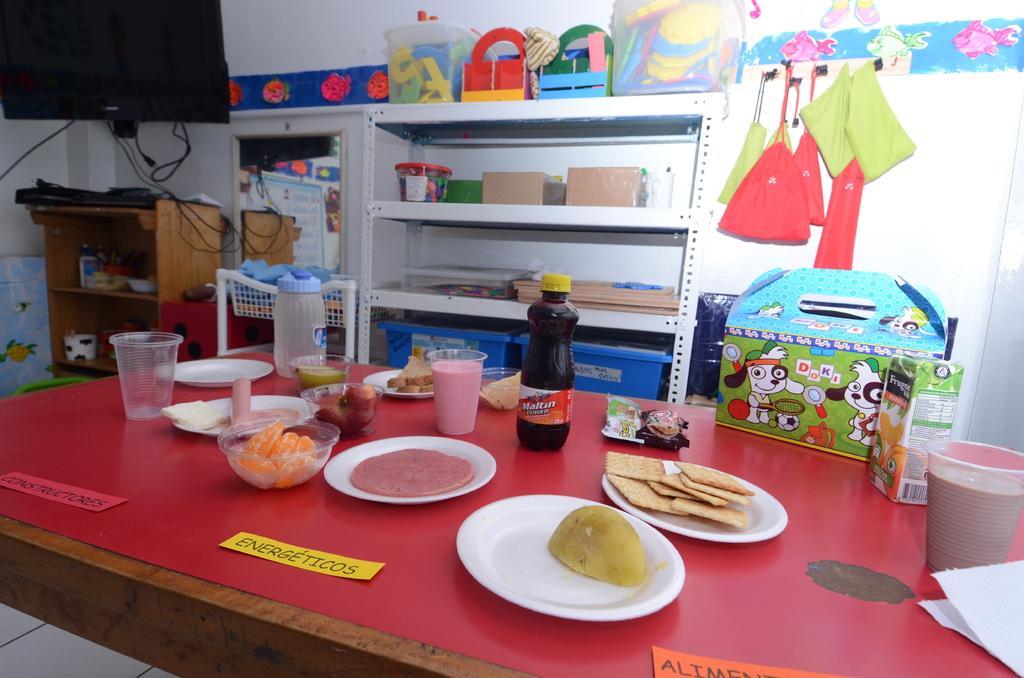Could you give a brief overview of what you see in this image? In this image, we can see wooden table, few items are placed on it. And back side, we can see bags are hanging, shelf few items are in it, basket, cupboard ,t. v. on left side ,some wall stickers, boards. 